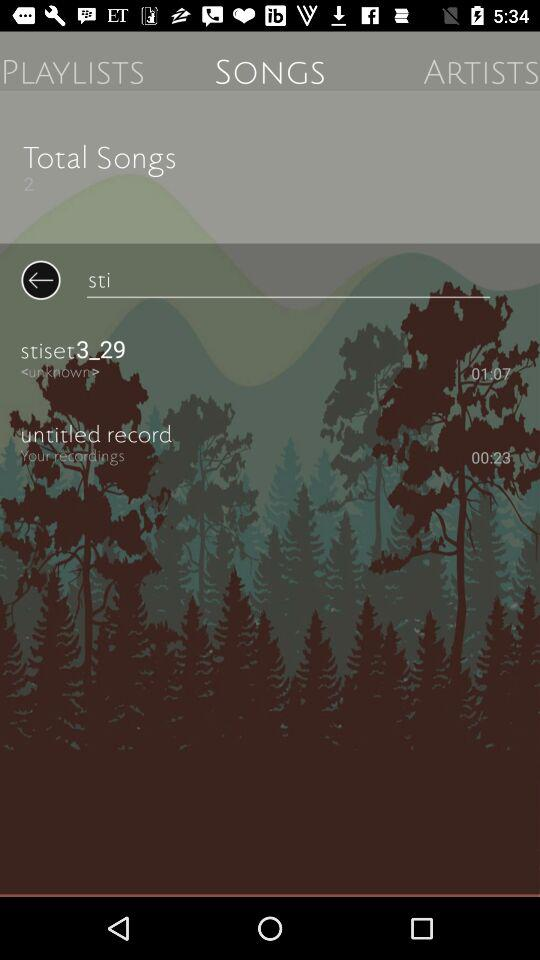What is the song "stiset3_29" duration? The duration is 1 minute and 7 seconds. 